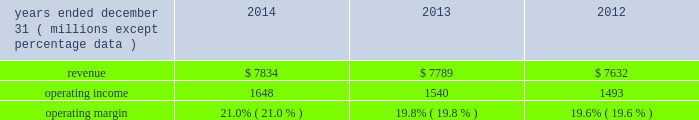Equity equity at december 31 , 2014 was $ 6.6 billion , a decrease of $ 1.6 billion from december 31 , 2013 .
The decrease resulted primarily due to share repurchases of $ 2.3 billion , $ 273 million of dividends to shareholders , and an increase in accumulated other comprehensive loss of $ 760 million , partially offset by net income of $ 1.4 billion .
The $ 760 million increase in accumulated other comprehensive loss from december 31 , 2013 , primarily reflects the following : 2022 negative net foreign currency translation adjustments of $ 504 million , which are attributable to the strengthening of the u.s .
Dollar against certain foreign currencies , 2022 an increase of $ 260 million in net post-retirement benefit obligations , 2022 net derivative gains of $ 5 million , and 2022 net investment losses of $ 1 million .
Review by segment general we serve clients through the following segments : 2022 risk solutions acts as an advisor and insurance and reinsurance broker , helping clients manage their risks , via consultation , as well as negotiation and placement of insurance risk with insurance carriers through our global distribution network .
2022 hr solutions partners with organizations to solve their most complex benefits , talent and related financial challenges , and improve business performance by designing , implementing , communicating and administering a wide range of human capital , retirement , investment management , health care , compensation and talent management strategies .
Risk solutions .
The demand for property and casualty insurance generally rises as the overall level of economic activity increases and generally falls as such activity decreases , affecting both the commissions and fees generated by our brokerage business .
The economic activity that impacts property and casualty insurance is described as exposure units , and is most closely correlated with employment levels , corporate revenue and asset values .
During 2014 , pricing was flat on average globally , and we would still consider this to be a "soft market." in a soft market , premium rates flatten or decrease , along with commission revenues , due to increased competition for market share among insurance carriers or increased underwriting capacity .
Changes in premiums have a direct and potentially material impact on the insurance brokerage industry , as commission revenues are generally based on a percentage of the premiums paid by insureds .
Additionally , continuing through 2014 , we faced difficult conditions as a result of continued weakness in the global economy , the repricing of credit risk and the deterioration of the financial markets .
Weak economic conditions in many markets around the globe have reduced our customers' demand for our retail brokerage and reinsurance brokerage products , which have had a negative impact on our operational results .
Risk solutions generated approximately 65% ( 65 % ) of our consolidated total revenues in 2014 .
Revenues are generated primarily through fees paid by clients , commissions and fees paid by insurance and reinsurance companies , and investment income on funds held on behalf of clients .
Our revenues vary from quarter to quarter throughout the year as a result of the timing of our clients' policy renewals , the net effect of new and lost business , the timing of services provided to our clients , and the income we earn on investments , which is heavily influenced by short-term interest rates .
We operate in a highly competitive industry and compete with many retail insurance brokerage and agency firms , as well as with individual brokers , agents , and direct writers of insurance coverage .
Specifically , we address the highly specialized .
What is the fluctuation between the lowest and average operating margin? 
Rationale: it is the difference between the average and the minimum value .
Computations: subtract(table_average(operating margin, none), table_min(operating margin, none))
Answer: 0.00533. 